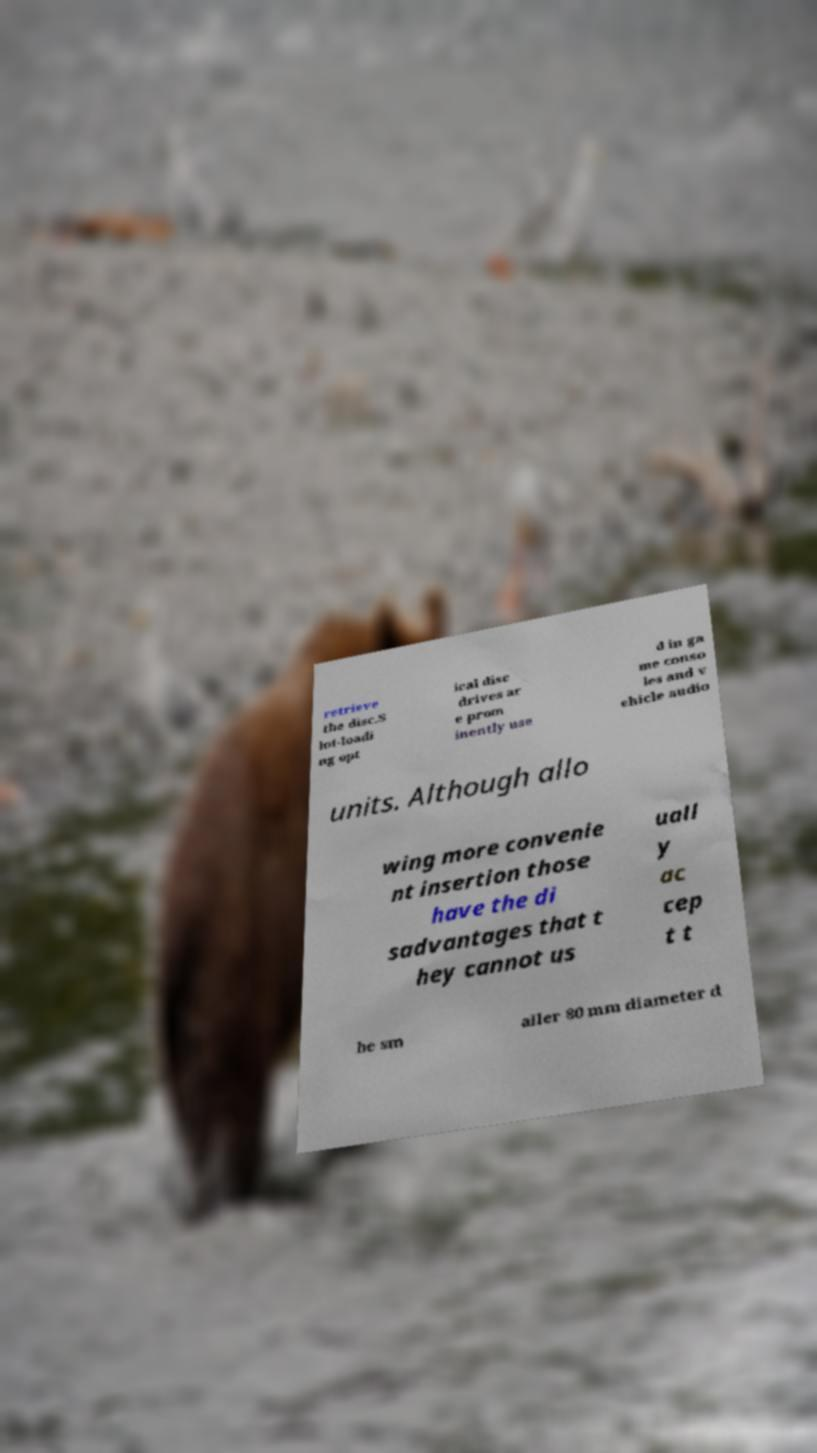Could you extract and type out the text from this image? retrieve the disc.S lot-loadi ng opt ical disc drives ar e prom inently use d in ga me conso les and v ehicle audio units. Although allo wing more convenie nt insertion those have the di sadvantages that t hey cannot us uall y ac cep t t he sm aller 80 mm diameter d 